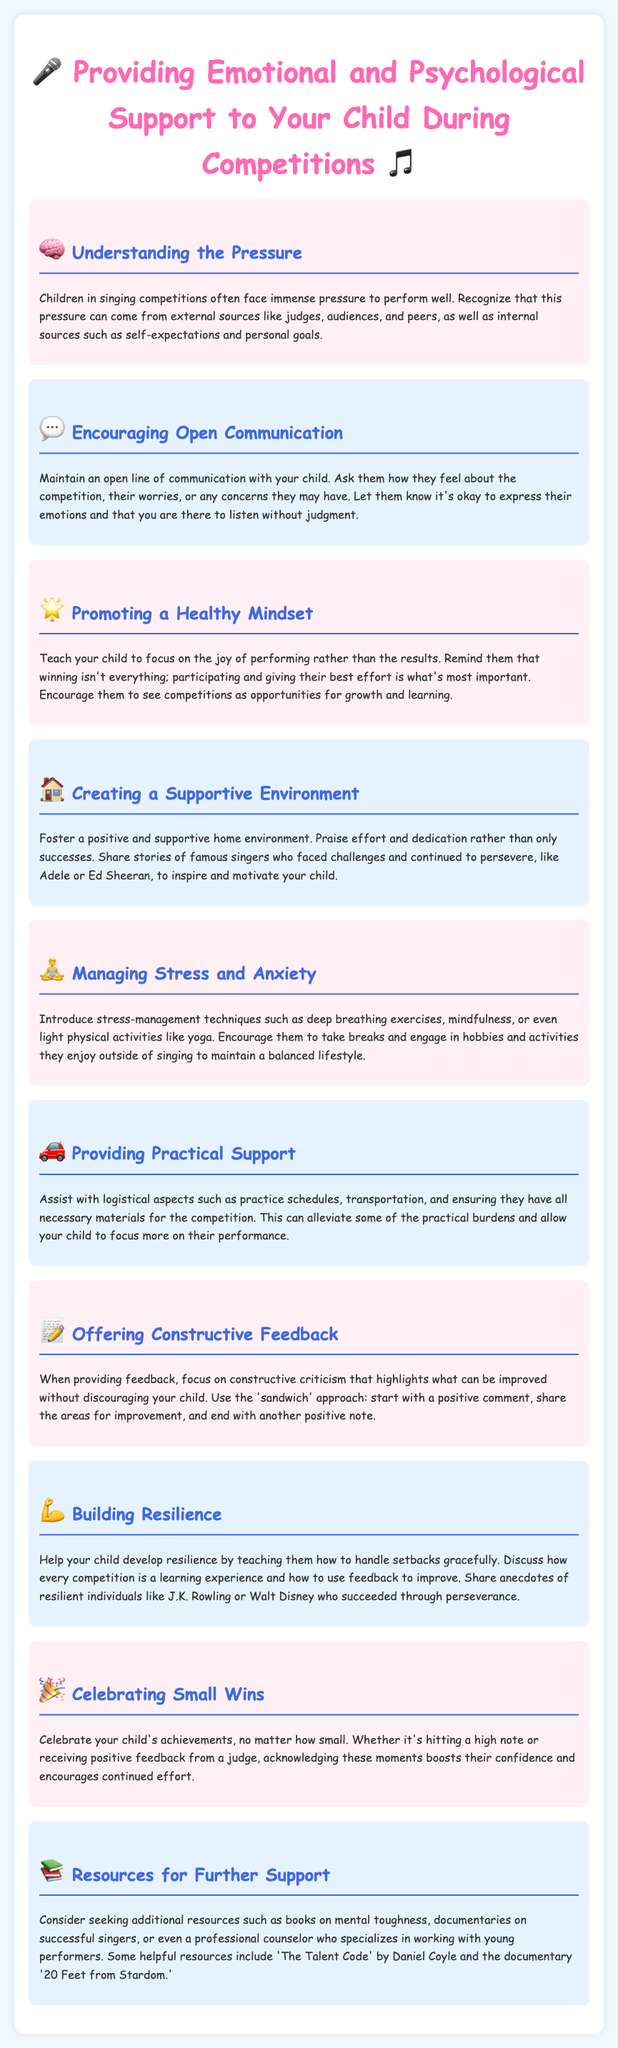What is the title of the document? The title is presented at the top of the document and describes the main theme of the content.
Answer: Supporting Your Child in Singing Competitions How many sections are in the document? The document contains multiple sections, each with a specific focus regarding emotional and psychological support.
Answer: 10 What should parents do to promote a healthy mindset in their child? The document suggests that parents should teach their child to focus on the joy of performing rather than the results.
Answer: Focus on the joy of performing What is a technique mentioned for managing stress and anxiety? The document lists various techniques that can help children cope with stress and anxiety before competitions.
Answer: Deep breathing exercises What approach is recommended for offering constructive feedback? The document provides a method for delivering feedback that ensures the child receives criticism in a supportive manner.
Answer: Sandwich approach What does the document suggest celebrating? The document emphasizes the importance of recognizing small achievements to boost the child’s confidence and motivation.
Answer: Small wins Who are two examples of resilient individuals mentioned in the guide? The document includes anecdotes of famous individuals to illustrate resilience, which can inspire children during competitions.
Answer: J.K. Rowling and Walt Disney What book is recommended for further support? The document provides resources that can help both parents and children better navigate the challenges of singing competitions.
Answer: The Talent Code What is the purpose of creating a supportive environment? The document mentions that a positive home environment can help children feel valued for their efforts, not just successes.
Answer: Praise effort and dedication What is the focus of the section "Understanding the Pressure"? This section addresses the various sources of pressure that children may face in competitions.
Answer: Sources of pressure 